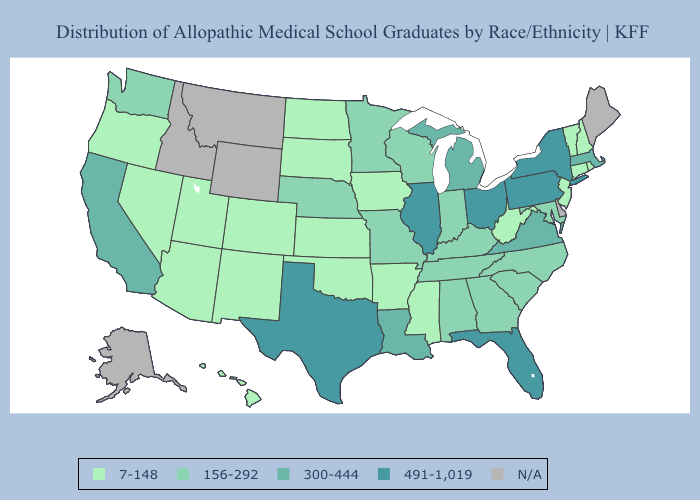Does the first symbol in the legend represent the smallest category?
Quick response, please. Yes. Name the states that have a value in the range N/A?
Concise answer only. Alaska, Delaware, Idaho, Maine, Montana, Wyoming. Among the states that border New Mexico , does Texas have the lowest value?
Write a very short answer. No. What is the highest value in the Northeast ?
Keep it brief. 491-1,019. What is the lowest value in states that border Iowa?
Short answer required. 7-148. Name the states that have a value in the range 7-148?
Be succinct. Arizona, Arkansas, Colorado, Connecticut, Hawaii, Iowa, Kansas, Mississippi, Nevada, New Hampshire, New Jersey, New Mexico, North Dakota, Oklahoma, Oregon, Rhode Island, South Dakota, Utah, Vermont, West Virginia. Name the states that have a value in the range 156-292?
Answer briefly. Alabama, Georgia, Indiana, Kentucky, Maryland, Minnesota, Missouri, Nebraska, North Carolina, South Carolina, Tennessee, Washington, Wisconsin. Among the states that border Washington , which have the lowest value?
Quick response, please. Oregon. Name the states that have a value in the range 156-292?
Give a very brief answer. Alabama, Georgia, Indiana, Kentucky, Maryland, Minnesota, Missouri, Nebraska, North Carolina, South Carolina, Tennessee, Washington, Wisconsin. What is the value of Mississippi?
Give a very brief answer. 7-148. Does the first symbol in the legend represent the smallest category?
Quick response, please. Yes. Does the map have missing data?
Be succinct. Yes. Does California have the highest value in the West?
Keep it brief. Yes. 